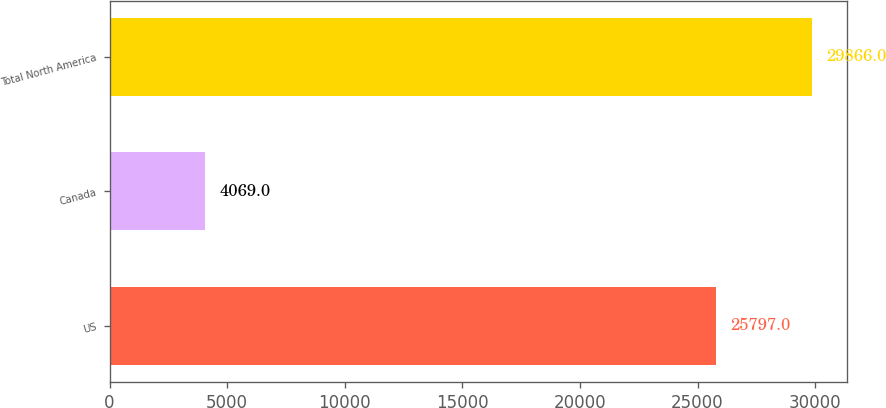<chart> <loc_0><loc_0><loc_500><loc_500><bar_chart><fcel>US<fcel>Canada<fcel>Total North America<nl><fcel>25797<fcel>4069<fcel>29866<nl></chart> 